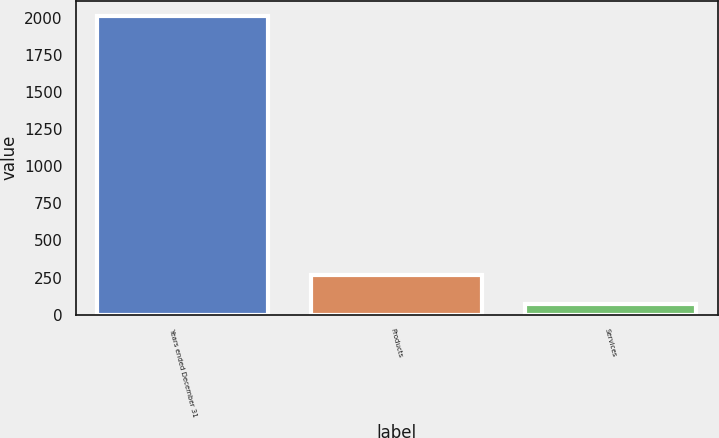Convert chart. <chart><loc_0><loc_0><loc_500><loc_500><bar_chart><fcel>Years ended December 31<fcel>Products<fcel>Services<nl><fcel>2014<fcel>268.9<fcel>75<nl></chart> 